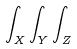<formula> <loc_0><loc_0><loc_500><loc_500>\int _ { X } \int _ { Y } \int _ { Z }</formula> 